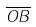<formula> <loc_0><loc_0><loc_500><loc_500>\overline { O B }</formula> 